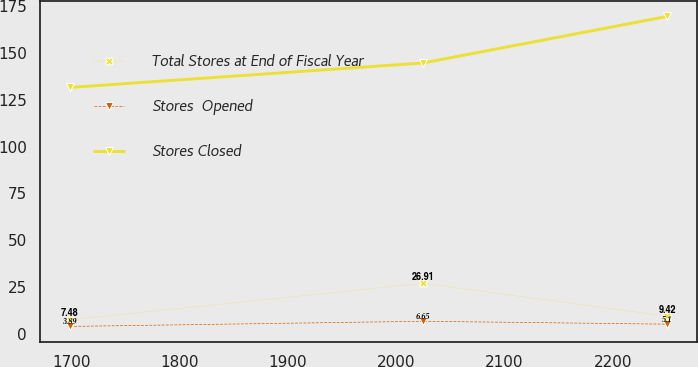Convert chart to OTSL. <chart><loc_0><loc_0><loc_500><loc_500><line_chart><ecel><fcel>Total Stores at End of Fiscal Year<fcel>Stores  Opened<fcel>Stores Closed<nl><fcel>1698.93<fcel>7.48<fcel>3.89<fcel>131.58<nl><fcel>2024.69<fcel>26.91<fcel>6.65<fcel>144.64<nl><fcel>2250.36<fcel>9.42<fcel>5.1<fcel>169.52<nl></chart> 